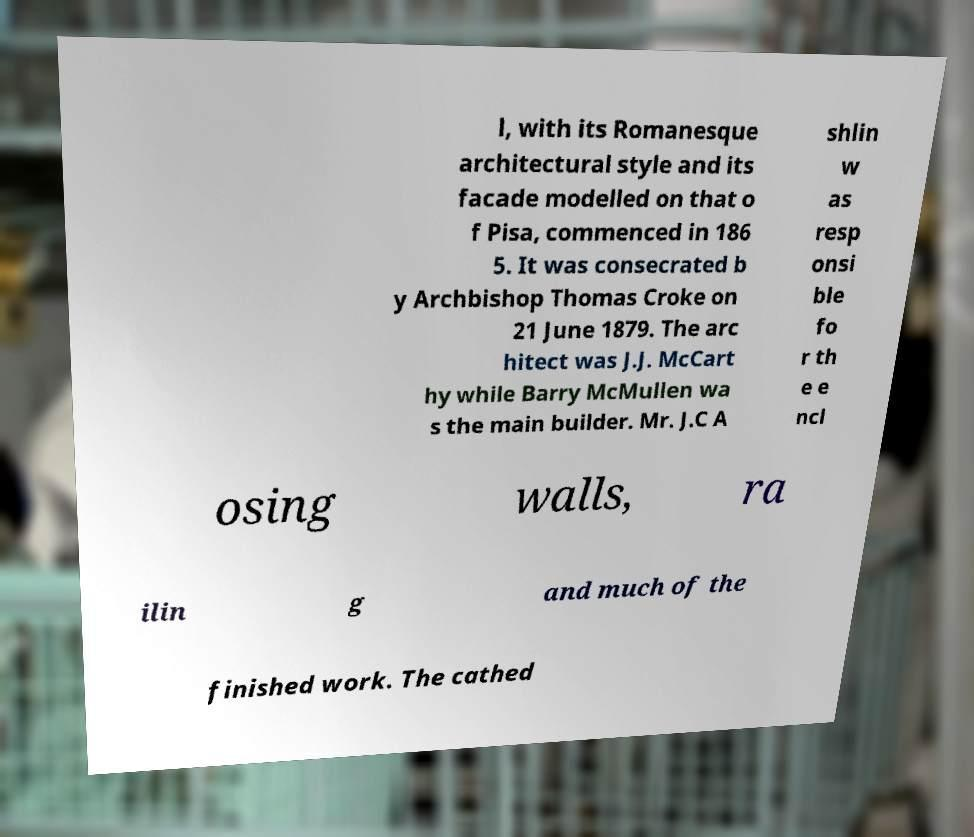I need the written content from this picture converted into text. Can you do that? l, with its Romanesque architectural style and its facade modelled on that o f Pisa, commenced in 186 5. It was consecrated b y Archbishop Thomas Croke on 21 June 1879. The arc hitect was J.J. McCart hy while Barry McMullen wa s the main builder. Mr. J.C A shlin w as resp onsi ble fo r th e e ncl osing walls, ra ilin g and much of the finished work. The cathed 